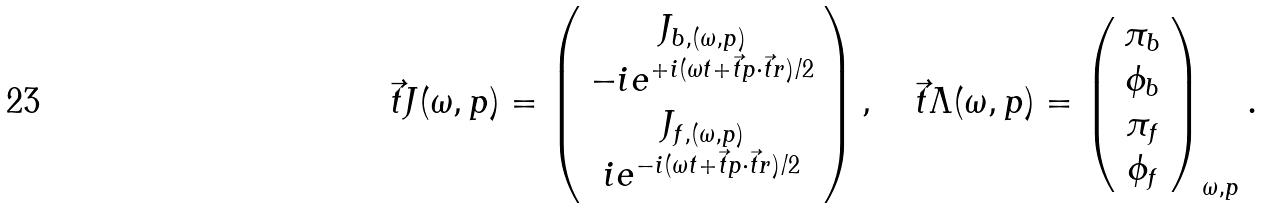Convert formula to latex. <formula><loc_0><loc_0><loc_500><loc_500>\vec { t } { J } ( \omega , p ) = \left ( \begin{array} { c } J _ { b , ( \omega , p ) } \\ - i e ^ { + i ( \omega t + \vec { t } { p } \cdot \vec { t } { r } ) / 2 } \\ J _ { f , ( \omega , p ) } \\ i e ^ { - i ( \omega t + \vec { t } { p } \cdot \vec { t } { r } ) / 2 } \end{array} \right ) , \quad \vec { t } { \Lambda } ( \omega , p ) = \left ( \begin{array} { c } \pi _ { b } \\ \phi _ { b } \\ \pi _ { f } \\ \phi _ { f } \end{array} \right ) _ { \omega , p } .</formula> 